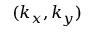<formula> <loc_0><loc_0><loc_500><loc_500>( k _ { x } , k _ { y } )</formula> 